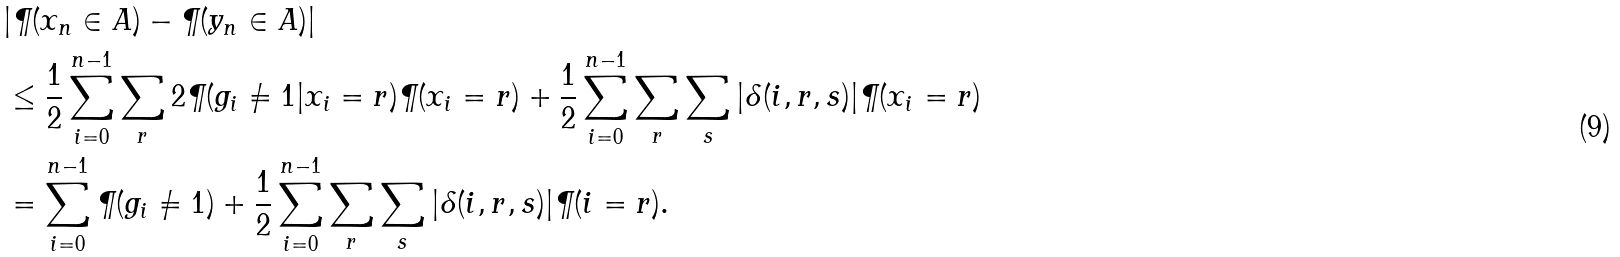Convert formula to latex. <formula><loc_0><loc_0><loc_500><loc_500>& | \P ( x _ { n } \in A ) - \P ( y _ { n } \in A ) | \\ & \leq \frac { 1 } { 2 } \sum _ { i = 0 } ^ { n - 1 } \sum _ { r } 2 \P ( g _ { i } \ne 1 | x _ { i } = r ) \P ( x _ { i } = r ) + \frac { 1 } { 2 } \sum _ { i = 0 } ^ { n - 1 } \sum _ { r } \sum _ { s } | \delta ( i , r , s ) | \P ( x _ { i } = r ) \\ & = \sum _ { i = 0 } ^ { n - 1 } \P ( g _ { i } \ne 1 ) + \frac { 1 } { 2 } \sum _ { i = 0 } ^ { n - 1 } \sum _ { r } \sum _ { s } | \delta ( i , r , s ) | \P ( i = r ) .</formula> 